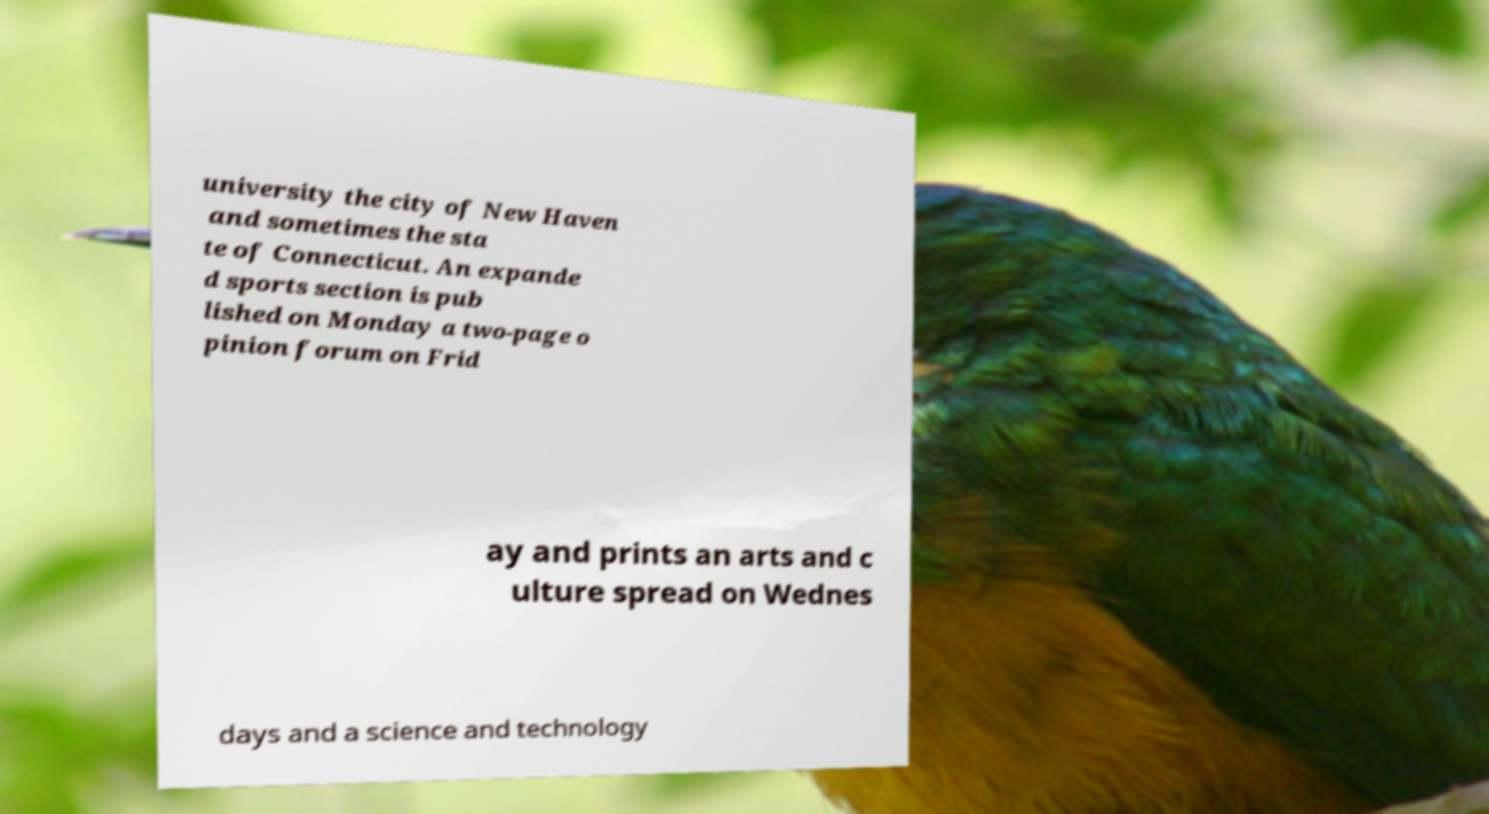Please read and relay the text visible in this image. What does it say? university the city of New Haven and sometimes the sta te of Connecticut. An expande d sports section is pub lished on Monday a two-page o pinion forum on Frid ay and prints an arts and c ulture spread on Wednes days and a science and technology 